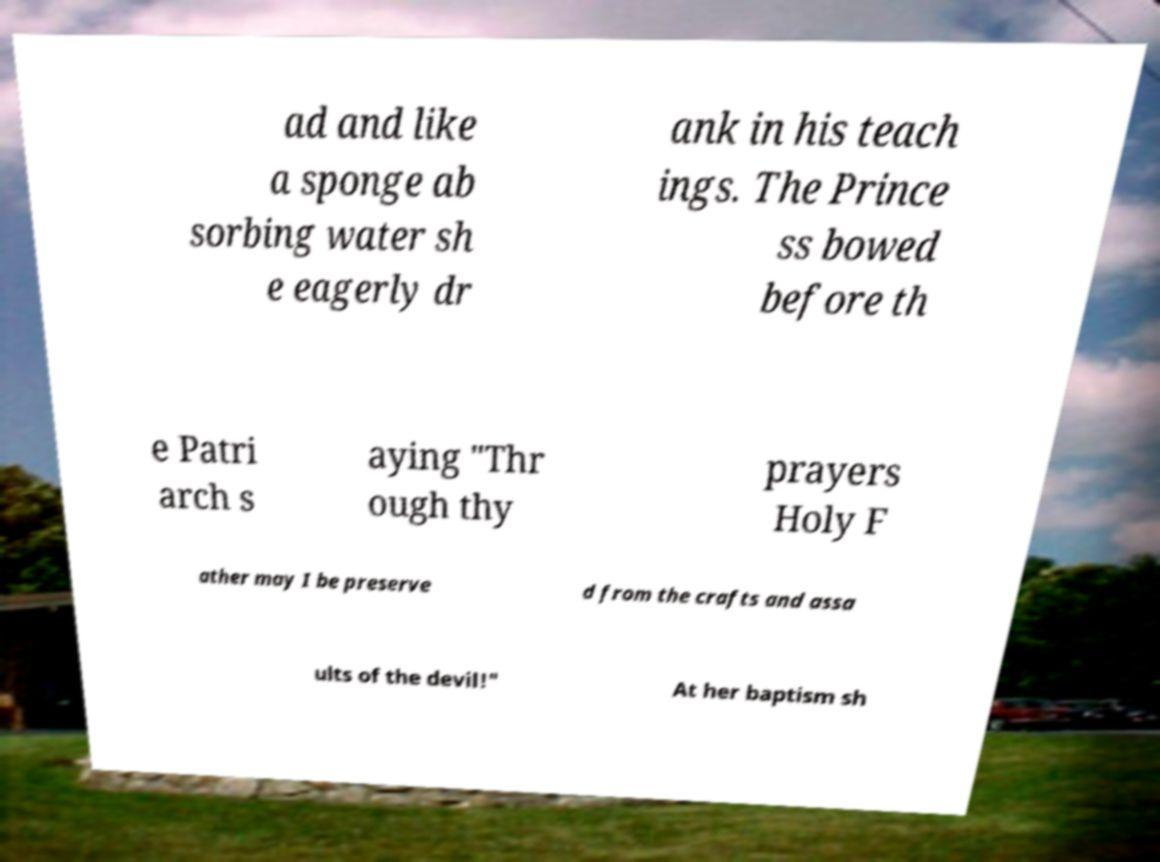For documentation purposes, I need the text within this image transcribed. Could you provide that? ad and like a sponge ab sorbing water sh e eagerly dr ank in his teach ings. The Prince ss bowed before th e Patri arch s aying "Thr ough thy prayers Holy F ather may I be preserve d from the crafts and assa ults of the devil!" At her baptism sh 